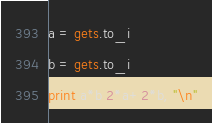Convert code to text. <code><loc_0><loc_0><loc_500><loc_500><_Ruby_>a = gets.to_i
b = gets.to_i
print a*b 2*a+2*b, "\n"</code> 